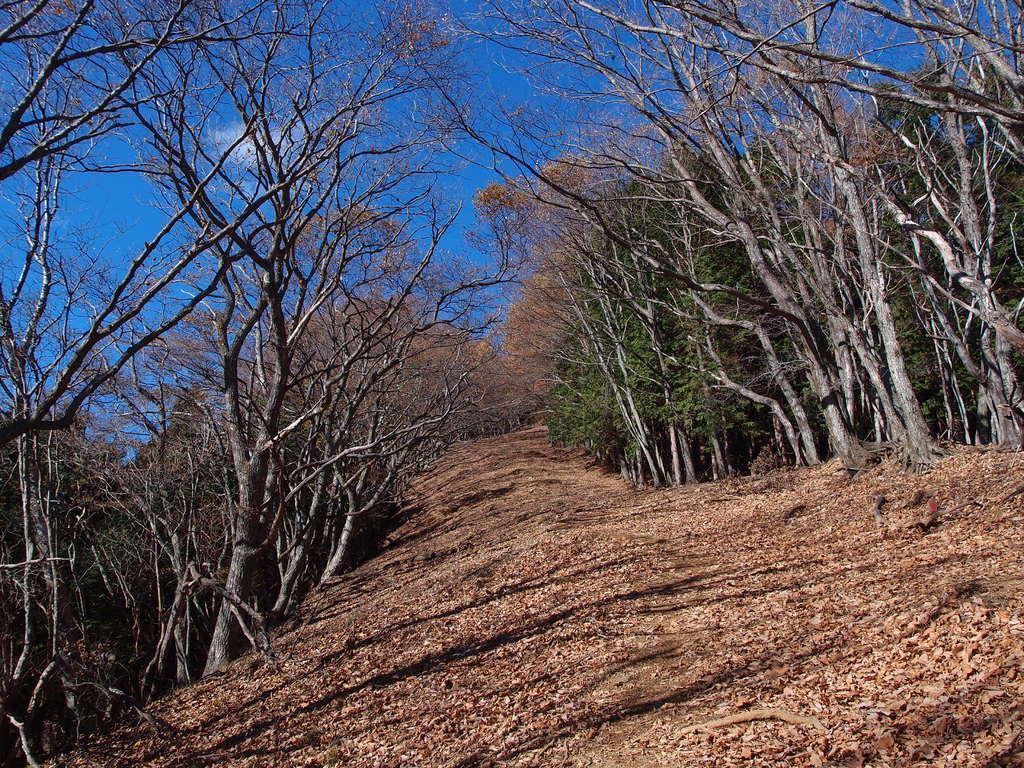Please provide a concise description of this image. In this image I can see the dried leaves on the ground. To the side I can see many trees. In the background I can see the blue sky. 